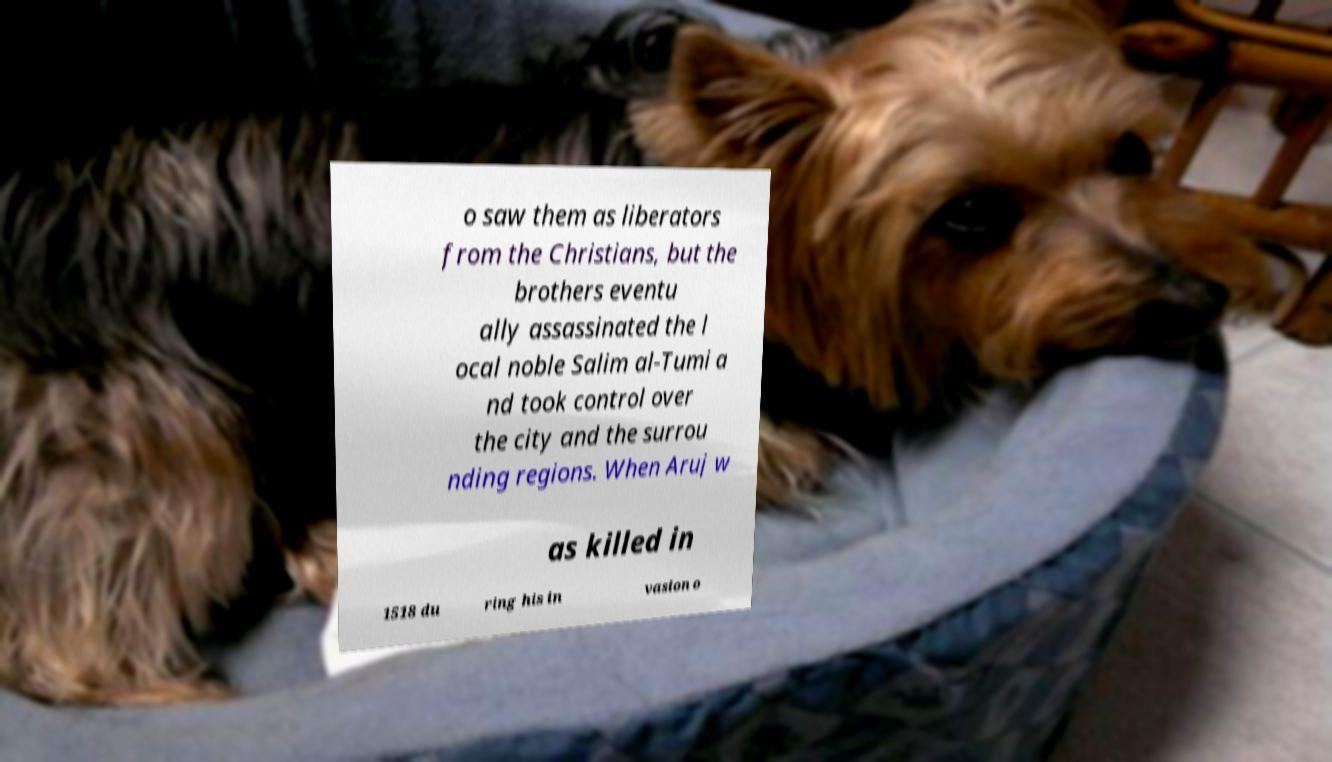Please identify and transcribe the text found in this image. o saw them as liberators from the Christians, but the brothers eventu ally assassinated the l ocal noble Salim al-Tumi a nd took control over the city and the surrou nding regions. When Aruj w as killed in 1518 du ring his in vasion o 